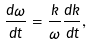<formula> <loc_0><loc_0><loc_500><loc_500>\frac { d \omega } { d t } = \frac { k } { \omega } \frac { d k } { d t } ,</formula> 